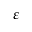Convert formula to latex. <formula><loc_0><loc_0><loc_500><loc_500>\varepsilon</formula> 